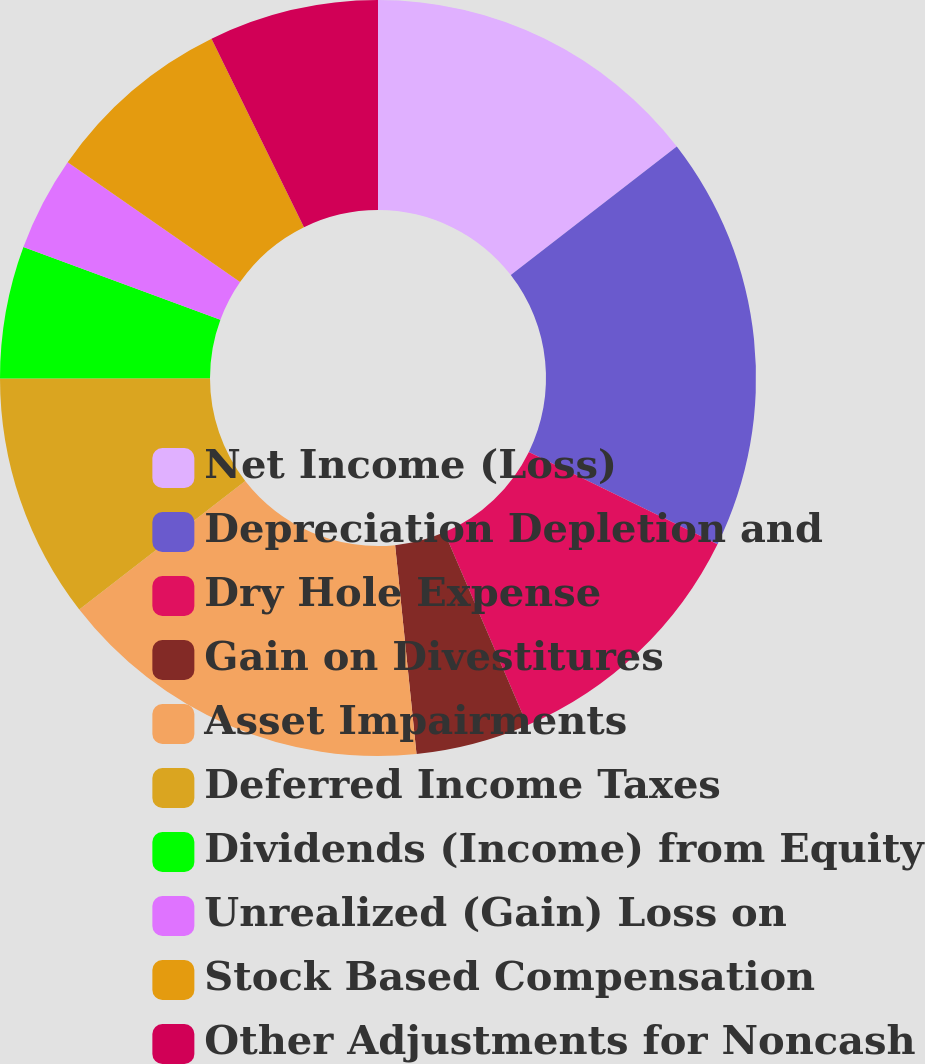<chart> <loc_0><loc_0><loc_500><loc_500><pie_chart><fcel>Net Income (Loss)<fcel>Depreciation Depletion and<fcel>Dry Hole Expense<fcel>Gain on Divestitures<fcel>Asset Impairments<fcel>Deferred Income Taxes<fcel>Dividends (Income) from Equity<fcel>Unrealized (Gain) Loss on<fcel>Stock Based Compensation<fcel>Other Adjustments for Noncash<nl><fcel>14.51%<fcel>17.74%<fcel>11.29%<fcel>4.84%<fcel>16.13%<fcel>10.48%<fcel>5.65%<fcel>4.04%<fcel>8.07%<fcel>7.26%<nl></chart> 